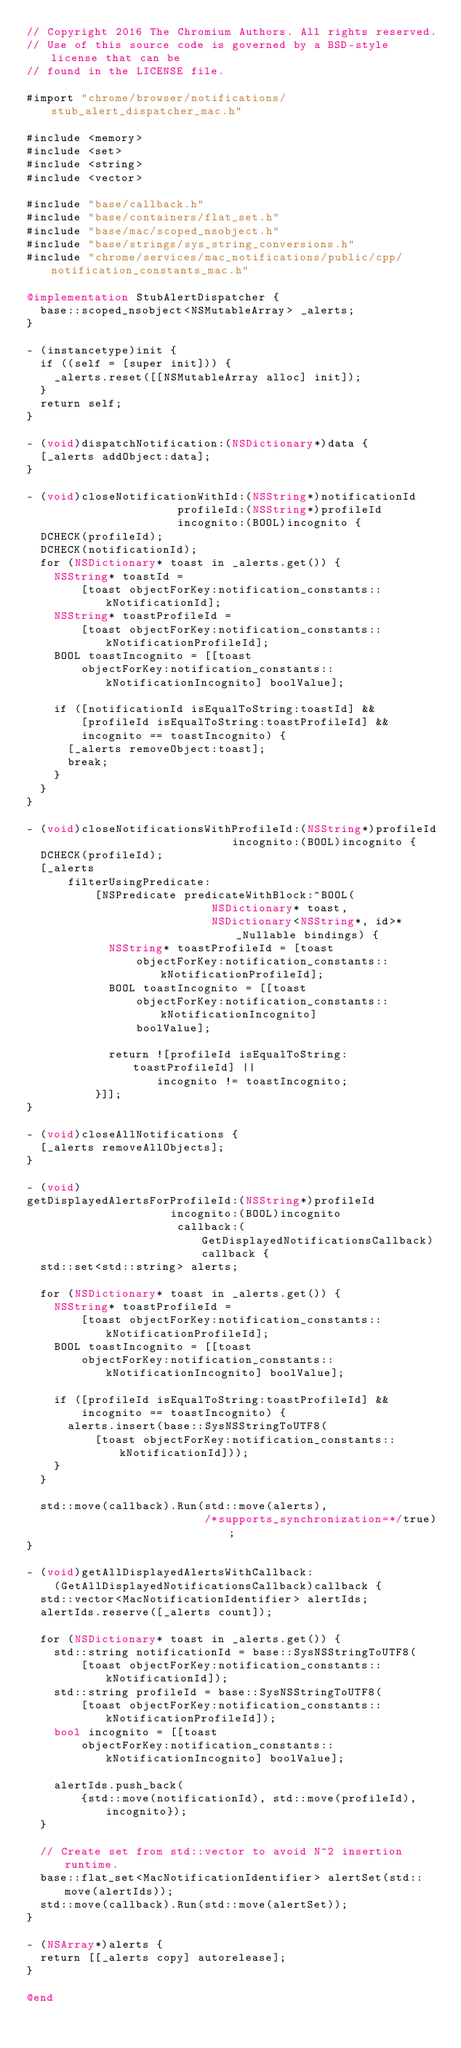<code> <loc_0><loc_0><loc_500><loc_500><_ObjectiveC_>// Copyright 2016 The Chromium Authors. All rights reserved.
// Use of this source code is governed by a BSD-style license that can be
// found in the LICENSE file.

#import "chrome/browser/notifications/stub_alert_dispatcher_mac.h"

#include <memory>
#include <set>
#include <string>
#include <vector>

#include "base/callback.h"
#include "base/containers/flat_set.h"
#include "base/mac/scoped_nsobject.h"
#include "base/strings/sys_string_conversions.h"
#include "chrome/services/mac_notifications/public/cpp/notification_constants_mac.h"

@implementation StubAlertDispatcher {
  base::scoped_nsobject<NSMutableArray> _alerts;
}

- (instancetype)init {
  if ((self = [super init])) {
    _alerts.reset([[NSMutableArray alloc] init]);
  }
  return self;
}

- (void)dispatchNotification:(NSDictionary*)data {
  [_alerts addObject:data];
}

- (void)closeNotificationWithId:(NSString*)notificationId
                      profileId:(NSString*)profileId
                      incognito:(BOOL)incognito {
  DCHECK(profileId);
  DCHECK(notificationId);
  for (NSDictionary* toast in _alerts.get()) {
    NSString* toastId =
        [toast objectForKey:notification_constants::kNotificationId];
    NSString* toastProfileId =
        [toast objectForKey:notification_constants::kNotificationProfileId];
    BOOL toastIncognito = [[toast
        objectForKey:notification_constants::kNotificationIncognito] boolValue];

    if ([notificationId isEqualToString:toastId] &&
        [profileId isEqualToString:toastProfileId] &&
        incognito == toastIncognito) {
      [_alerts removeObject:toast];
      break;
    }
  }
}

- (void)closeNotificationsWithProfileId:(NSString*)profileId
                              incognito:(BOOL)incognito {
  DCHECK(profileId);
  [_alerts
      filterUsingPredicate:
          [NSPredicate predicateWithBlock:^BOOL(
                           NSDictionary* toast,
                           NSDictionary<NSString*, id>* _Nullable bindings) {
            NSString* toastProfileId = [toast
                objectForKey:notification_constants::kNotificationProfileId];
            BOOL toastIncognito = [[toast
                objectForKey:notification_constants::kNotificationIncognito]
                boolValue];

            return ![profileId isEqualToString:toastProfileId] ||
                   incognito != toastIncognito;
          }]];
}

- (void)closeAllNotifications {
  [_alerts removeAllObjects];
}

- (void)
getDisplayedAlertsForProfileId:(NSString*)profileId
                     incognito:(BOOL)incognito
                      callback:(GetDisplayedNotificationsCallback)callback {
  std::set<std::string> alerts;

  for (NSDictionary* toast in _alerts.get()) {
    NSString* toastProfileId =
        [toast objectForKey:notification_constants::kNotificationProfileId];
    BOOL toastIncognito = [[toast
        objectForKey:notification_constants::kNotificationIncognito] boolValue];

    if ([profileId isEqualToString:toastProfileId] &&
        incognito == toastIncognito) {
      alerts.insert(base::SysNSStringToUTF8(
          [toast objectForKey:notification_constants::kNotificationId]));
    }
  }

  std::move(callback).Run(std::move(alerts),
                          /*supports_synchronization=*/true);
}

- (void)getAllDisplayedAlertsWithCallback:
    (GetAllDisplayedNotificationsCallback)callback {
  std::vector<MacNotificationIdentifier> alertIds;
  alertIds.reserve([_alerts count]);

  for (NSDictionary* toast in _alerts.get()) {
    std::string notificationId = base::SysNSStringToUTF8(
        [toast objectForKey:notification_constants::kNotificationId]);
    std::string profileId = base::SysNSStringToUTF8(
        [toast objectForKey:notification_constants::kNotificationProfileId]);
    bool incognito = [[toast
        objectForKey:notification_constants::kNotificationIncognito] boolValue];

    alertIds.push_back(
        {std::move(notificationId), std::move(profileId), incognito});
  }

  // Create set from std::vector to avoid N^2 insertion runtime.
  base::flat_set<MacNotificationIdentifier> alertSet(std::move(alertIds));
  std::move(callback).Run(std::move(alertSet));
}

- (NSArray*)alerts {
  return [[_alerts copy] autorelease];
}

@end
</code> 